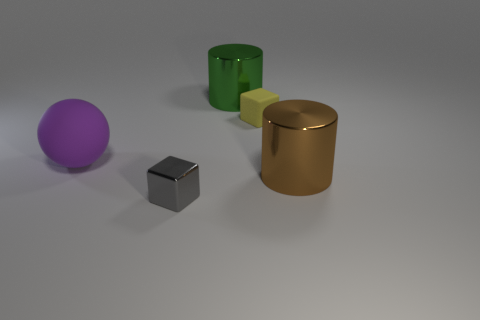There is a cube that is right of the big object that is behind the thing left of the small gray cube; what is its material?
Provide a short and direct response. Rubber. Is the number of purple matte objects right of the metallic block greater than the number of small metal blocks that are to the left of the big purple thing?
Your answer should be very brief. No. What number of cylinders are green matte objects or shiny objects?
Ensure brevity in your answer.  2. How many things are in front of the shiny thing behind the cube behind the gray metal cube?
Give a very brief answer. 4. Are there more rubber cubes than big blue rubber spheres?
Offer a terse response. Yes. Does the brown cylinder have the same size as the gray metallic cube?
Offer a very short reply. No. What number of things are either big green metal objects or large red shiny blocks?
Keep it short and to the point. 1. What is the shape of the rubber thing on the left side of the block that is in front of the large shiny cylinder that is in front of the purple matte sphere?
Offer a terse response. Sphere. Are the block to the right of the large green thing and the block on the left side of the yellow rubber block made of the same material?
Ensure brevity in your answer.  No. What material is the big brown object that is the same shape as the large green thing?
Keep it short and to the point. Metal. 